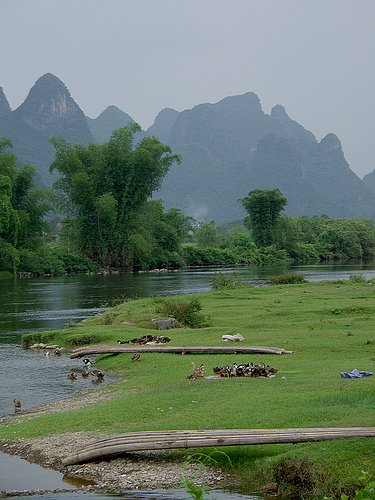<image>
Is there a tree in the water? Yes. The tree is contained within or inside the water, showing a containment relationship. 